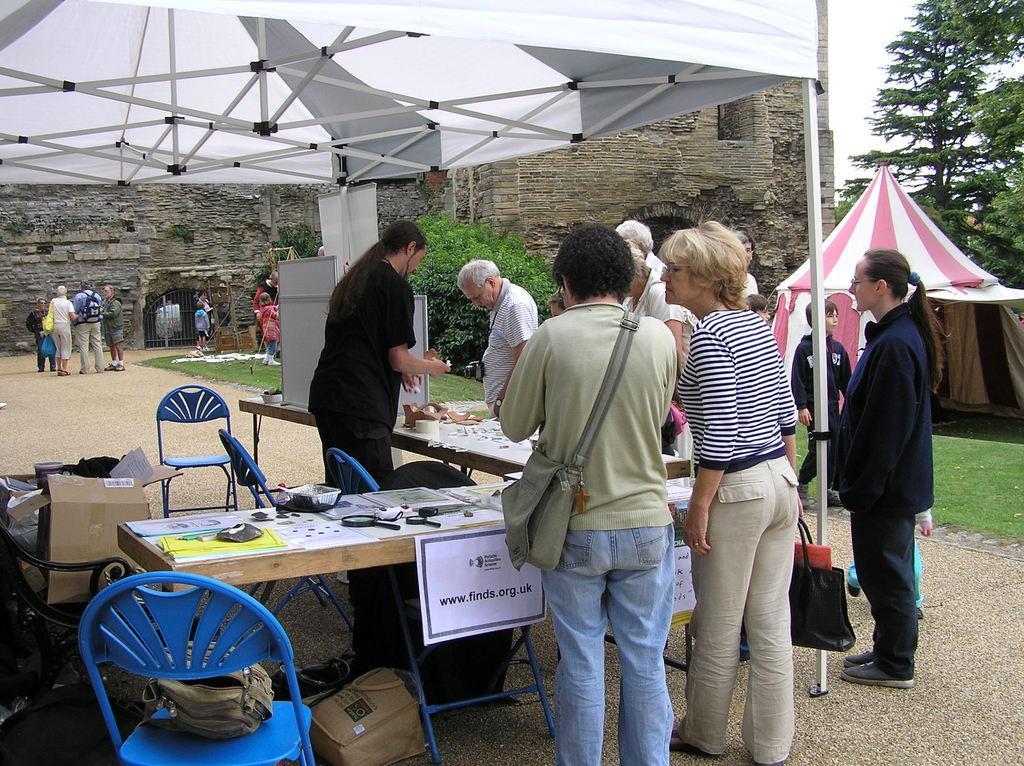Describe this image in one or two sentences. in the picture we can see a people standing near the table and chairs, a man is explaining something to a people. In the background we can see a historical building a plants, trees, and a tent which is pink and white in color. 